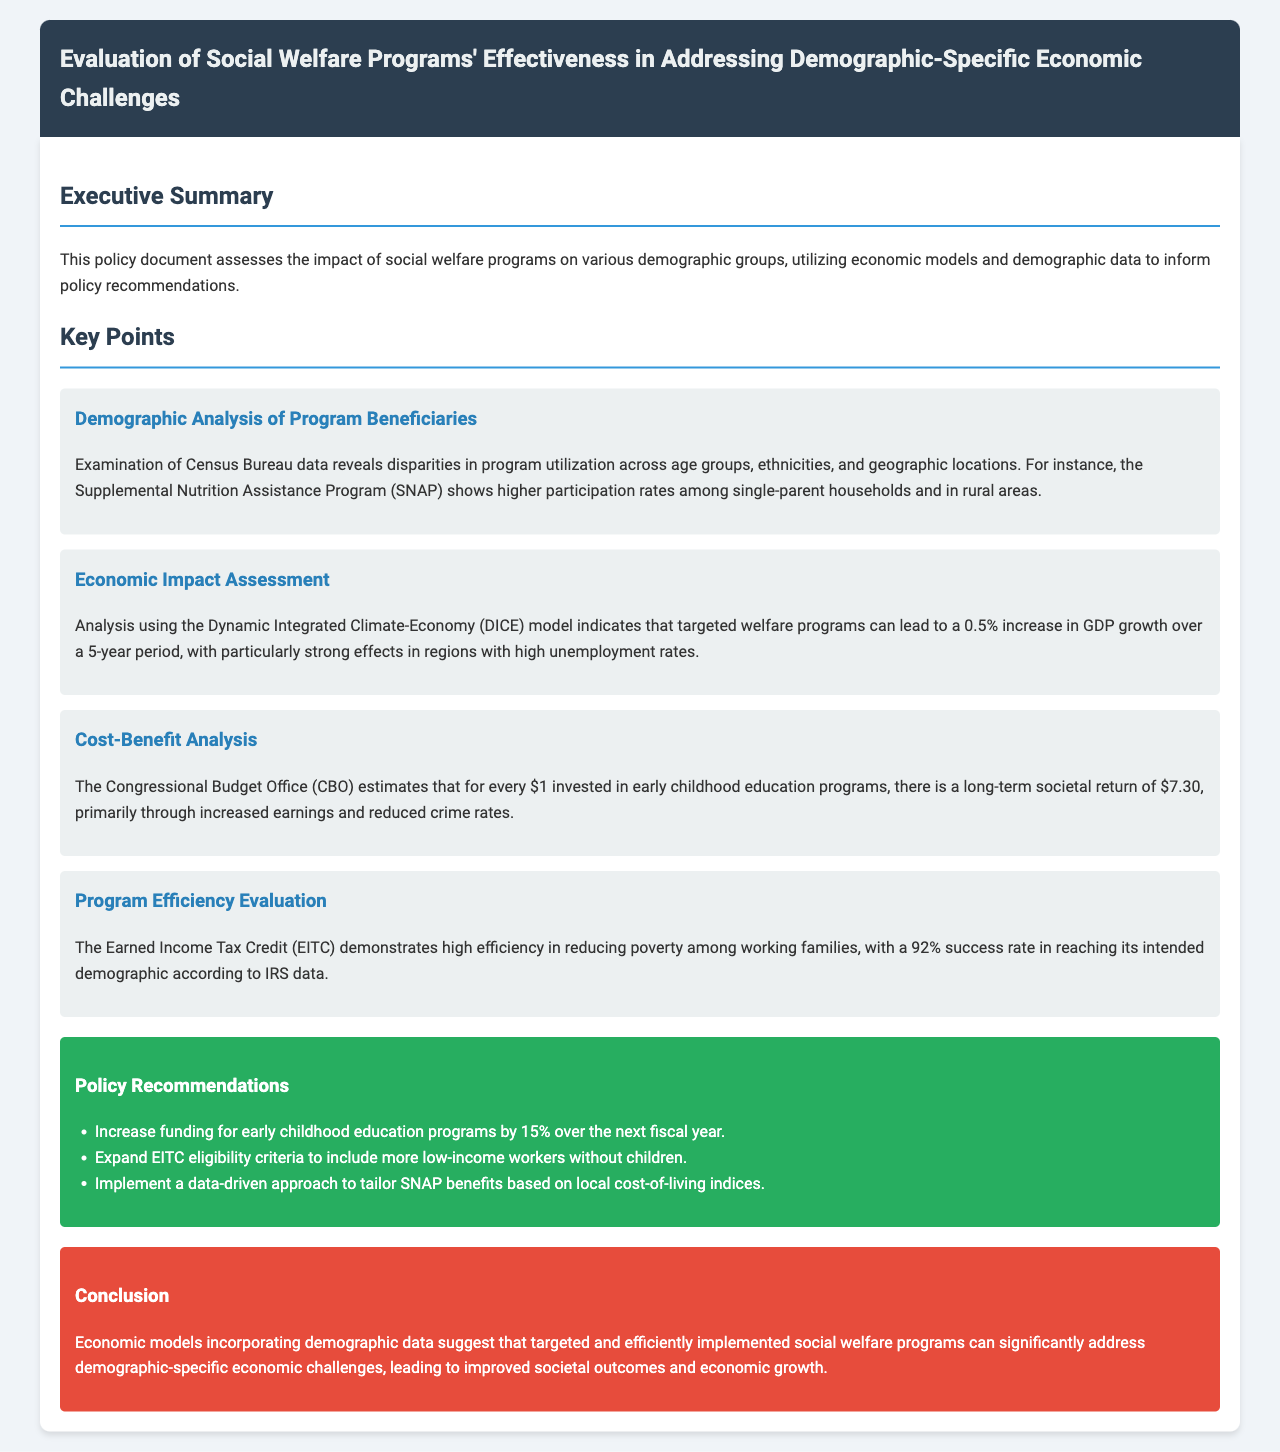What is the title of the document? The title is presented at the top of the header in the document.
Answer: Evaluation of Social Welfare Programs' Effectiveness in Addressing Demographic-Specific Economic Challenges What percentage increase in GDP growth is indicated by the analysis? The document states a percentage increase based on the analysis in the Economic Impact Assessment section.
Answer: 0.5% What program shows higher participation rates among single-parent households? This information is found in the Demographic Analysis of Program Beneficiaries section.
Answer: Supplemental Nutrition Assistance Program (SNAP) What is the long-term societal return for every $1 invested in early childhood education? The cost-benefit analysis section provides this specific figure.
Answer: $7.30 What is the success rate of the Earned Income Tax Credit (EITC) in reaching its intended demographic? This statistic is provided in the Program Efficiency Evaluation section of the document.
Answer: 92% What is one of the policy recommendations regarding early childhood education programs? The specific recommendation is stated under the Policy Recommendations section.
Answer: Increase funding for early childhood education programs by 15% What model is used to analyze the economic impact of welfare programs? The document mentions a specific model in the Economic Impact Assessment section.
Answer: Dynamic Integrated Climate-Economy (DICE) model Which demographic group was especially noted for utilizing SNAP in rural areas? This insight is noted in the Demographic Analysis of Program Beneficiaries.
Answer: Single-parent households 